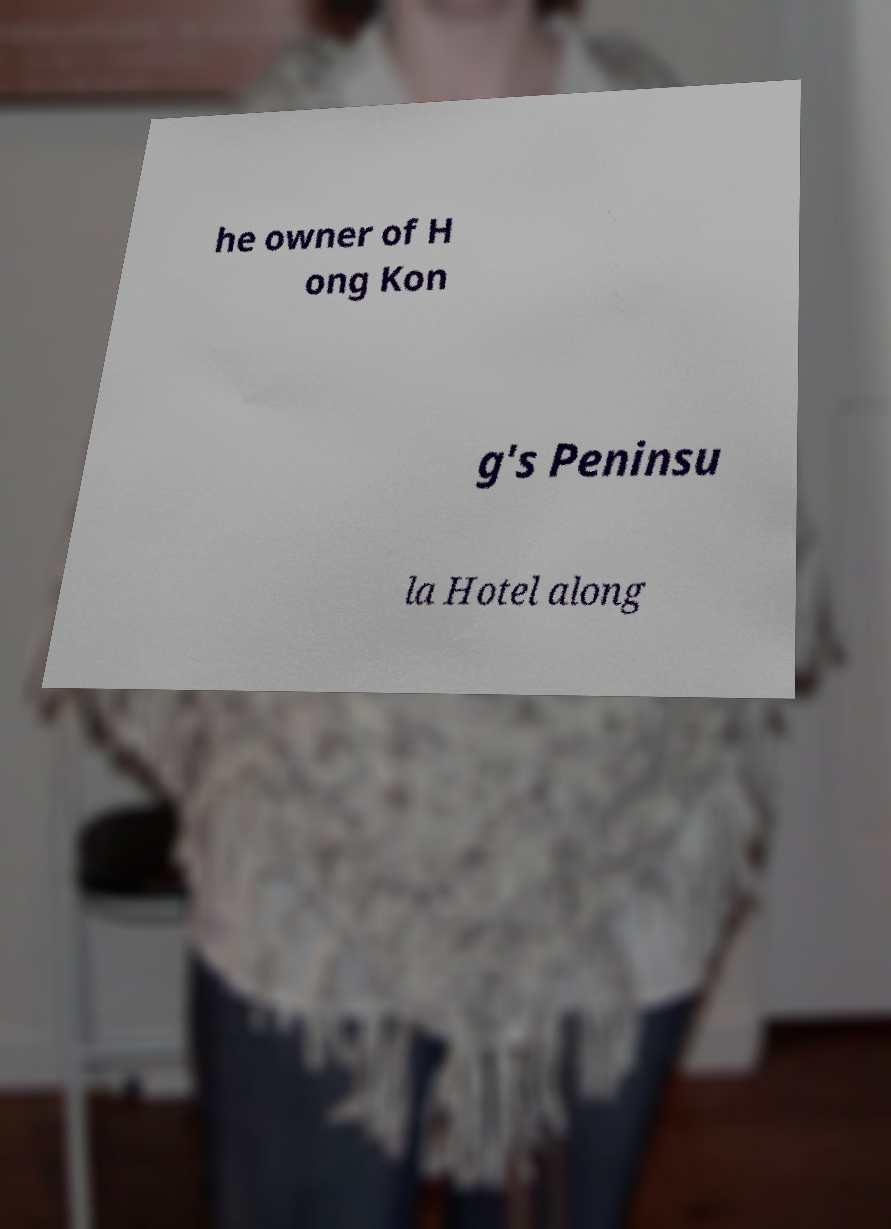There's text embedded in this image that I need extracted. Can you transcribe it verbatim? he owner of H ong Kon g's Peninsu la Hotel along 